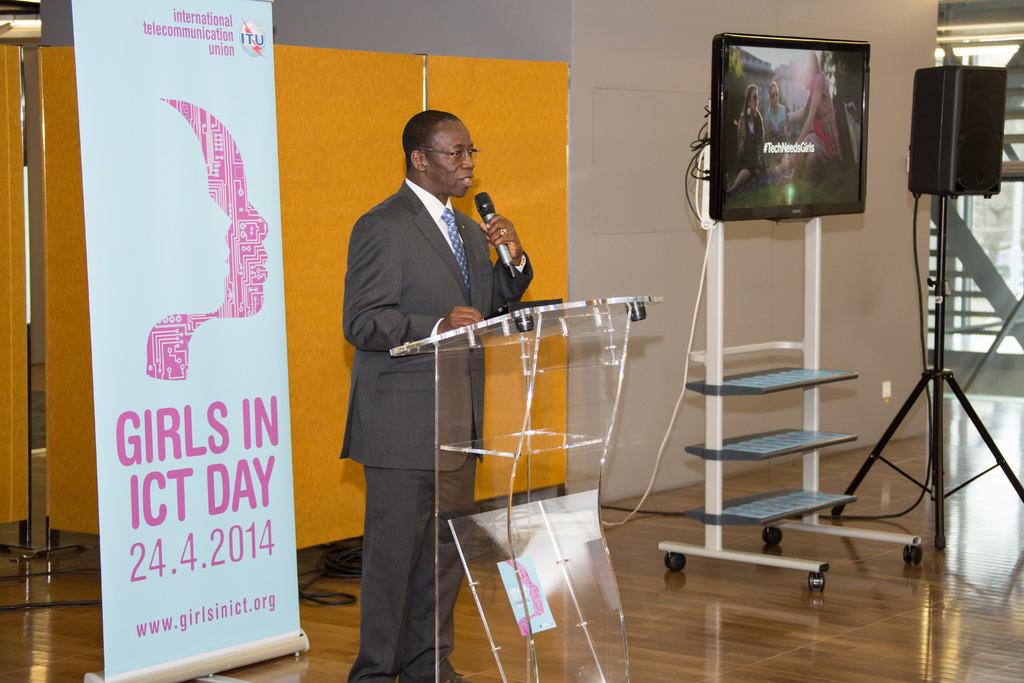<image>
Give a short and clear explanation of the subsequent image. speaker at a clear podium with a sign behind him for girls in ict day on 4/24/2014 